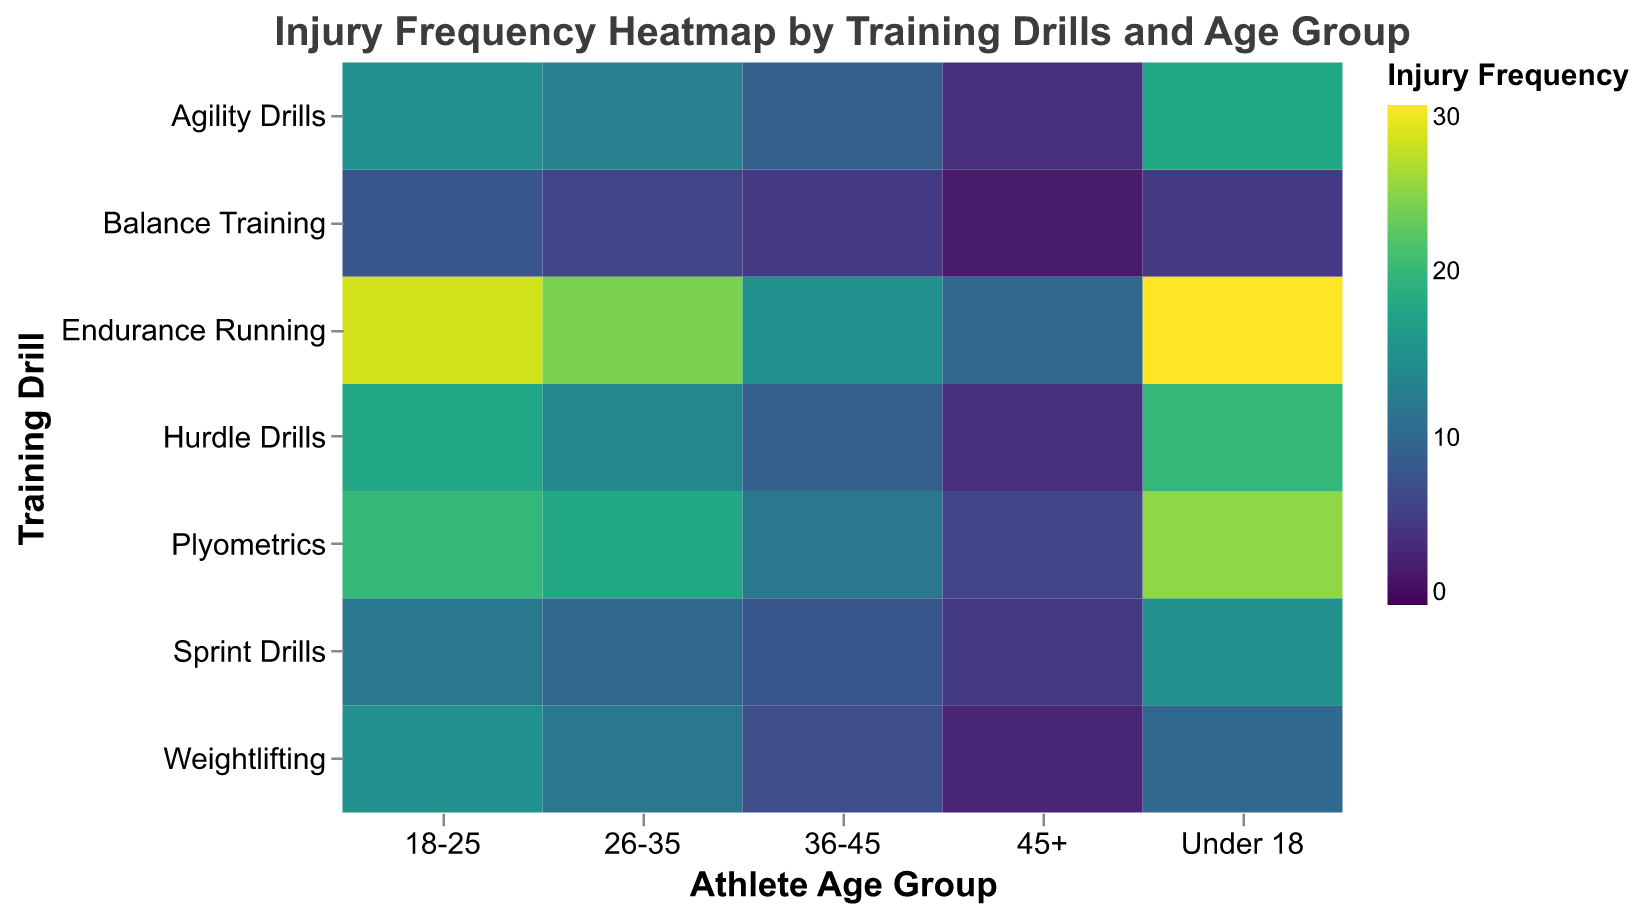What is the title of the heatmap? The title can be found at the top center of the figure. It states the main focus of the heatmap which allows viewers to understand the context instantly.
Answer: Injury Frequency Heatmap by Training Drills and Age Group Which training drill has the highest injury frequency for athletes under 18? To find this, look at the 'Under 18' column and identify the highest color intensity which correlates to the highest numerical value.
Answer: Endurance Running How does the injury frequency in Sprint Drills compare between athletes aged 18-25 and those aged 45+? Comparisons can be made by locating the 'Sprint Drills' row and comparing the values at '18-25' and '45+' columns.
Answer: The injury frequency is higher in the 18-25 age group (12) compared to the 45+ age group (5) What is the sum of injury frequencies for Plyometrics across all age groups? Summation involves adding the injury frequency values across all age groups for Plyometrics: 25 (Under 18) + 20 (18-25) + 18 (26-35) + 12 (36-45) + 6 (45+).
Answer: 81 Which age group has the lowest injury frequency for Weightlifting? By looking at the 'Weightlifting' row, locate the column with the lowest numerical value or the least color intensity to find the lowest injury frequency.
Answer: 45+ How does the injury frequency in Balance Training for the 26-35 age group compare to that of Hurdle Drills for the same age group? Identify the values in the '26-35' column for both 'Balance Training' and 'Hurdle Drills' rows, and then compare them.
Answer: The injury frequency is higher for Hurdle Drills (14) compared to Balance Training (6) What is the median injury frequency for Endurance Running across all age groups? To find the median, list the injury frequencies for Endurance Running in ascending order and find the middle value: 10, 15, 24, 28, 30. The median value is the third number.
Answer: 24 Which training drill has the most consistent injury frequency across all age groups (smallest range)? To determine consistency, calculate the range (difference between maximum and minimum values) of injury frequencies for each training drill and find the one with the smallest difference.
Answer: Balance Training How many training drills have an injury frequency above 15 for the 18-25 age group? Count the number of 'Drill' names in the '18-25' column where the injury frequency value is greater than 15.
Answer: 3 (Endurance Running, Plyometrics, Hurdle Drills) What is the average injury frequency of athletes under 18 across all training drills? Calculate the average by summing all injury frequency values for 'Under 18' column and then dividing by the number of training drills: (15 + 20 + 10 + 25 + 5 + 30 + 18) / 7.
Answer: 17.57 